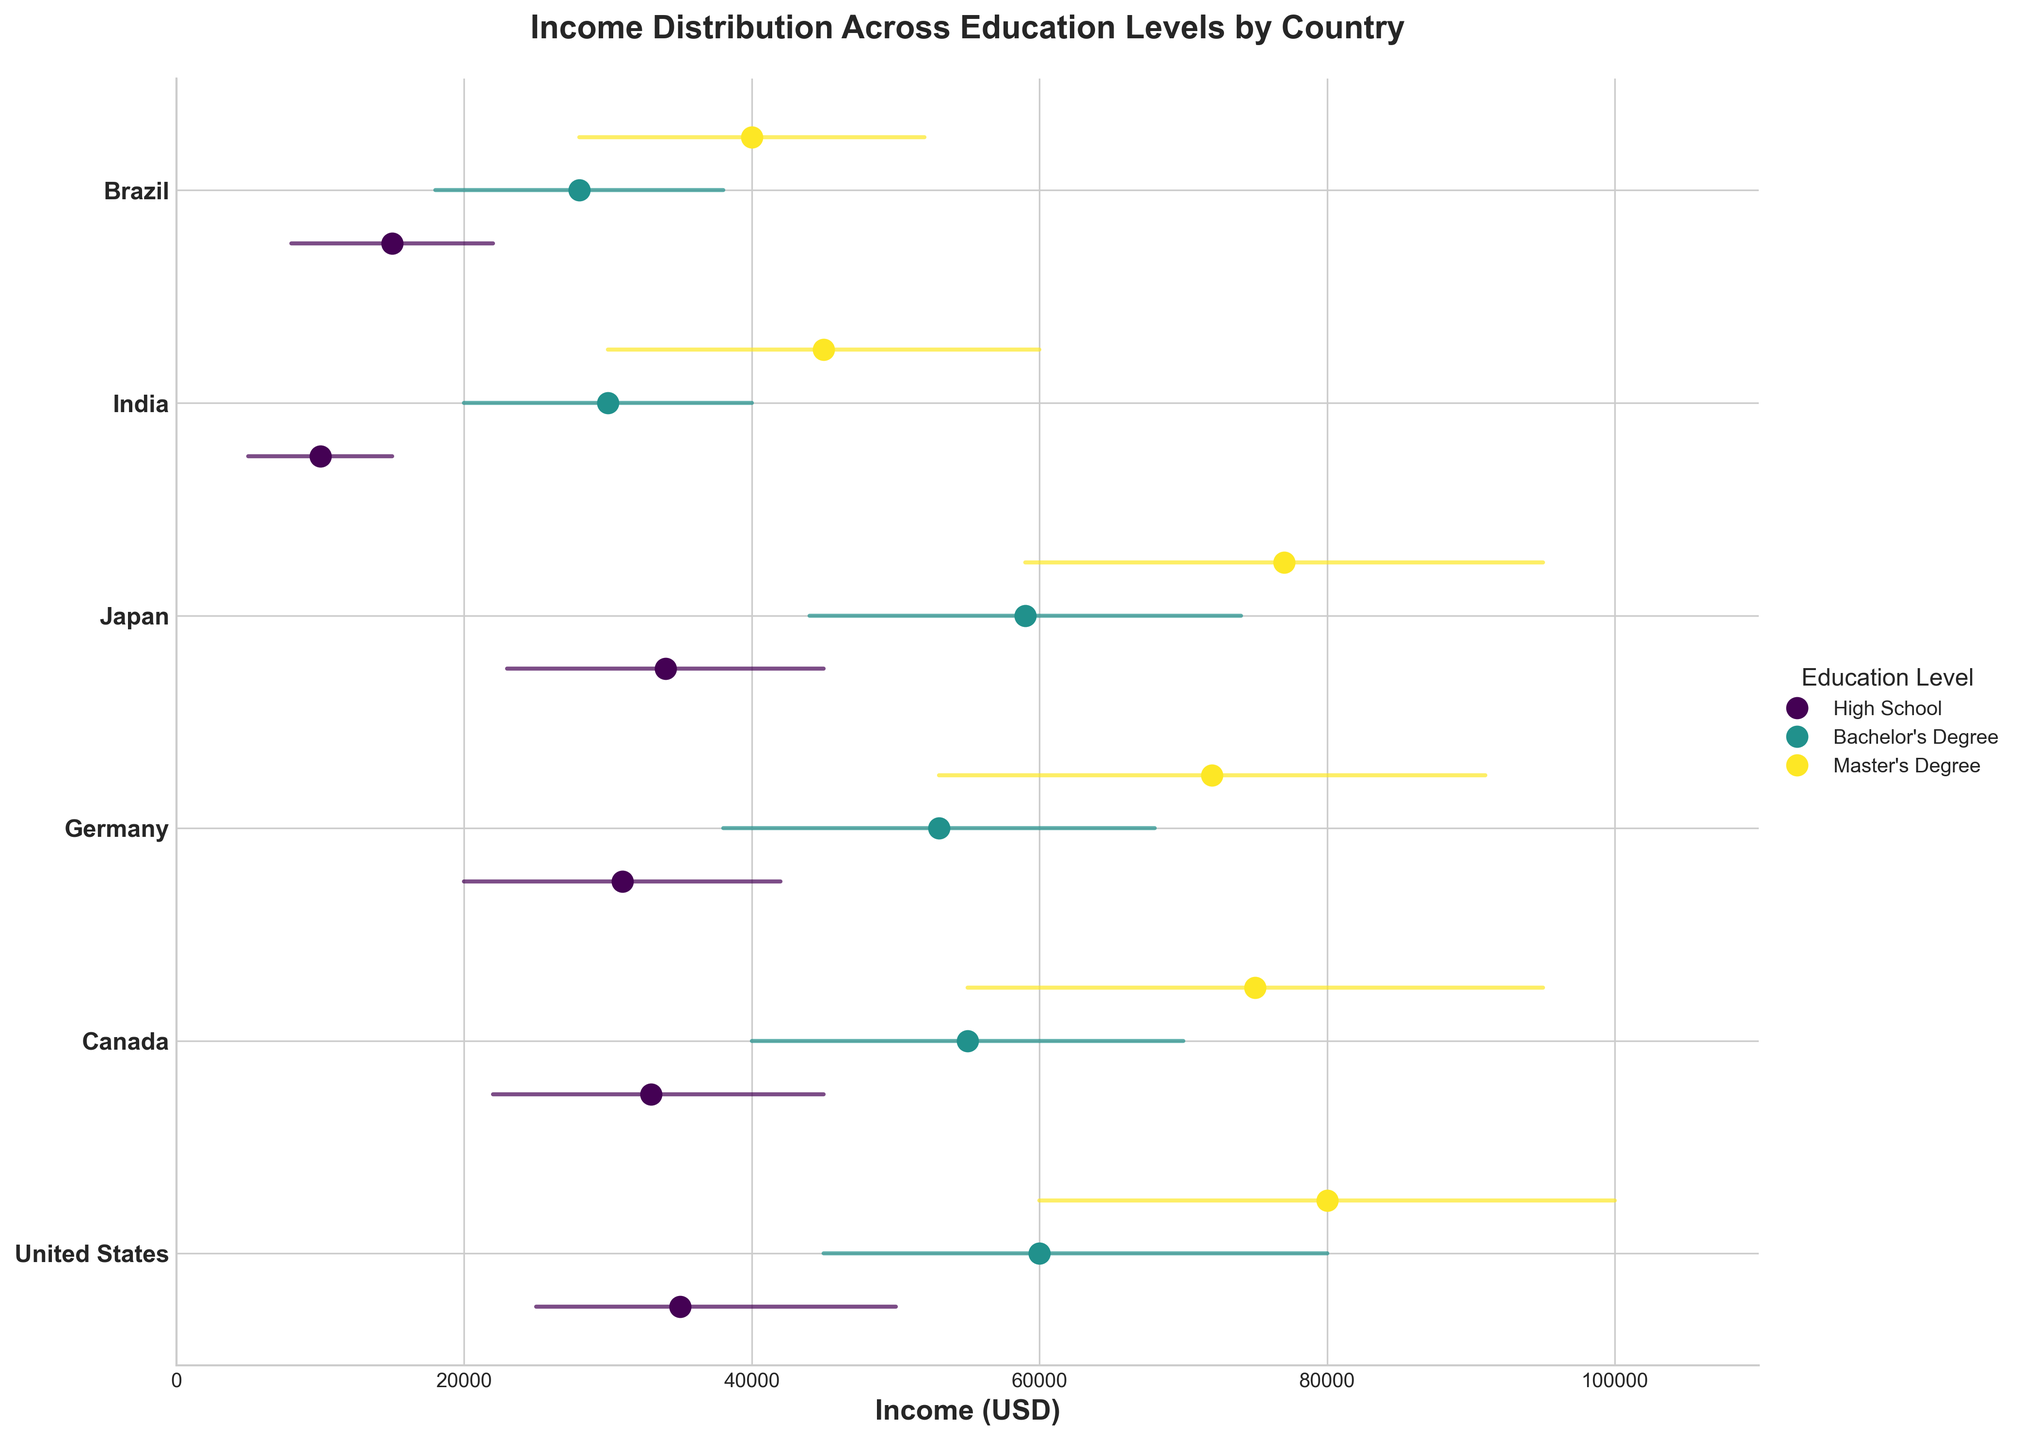What's the title of the figure? The title is displayed at the top of the figure in a larger and bold font. It reads "Income Distribution Across Education Levels by Country."
Answer: Income Distribution Across Education Levels by Country What is the median income for individuals with a Master's Degree in Germany? Look at the dot for "Germany" in the "Master's Degree" series. The label next to it provides the median income value.
Answer: 72000 Which country has the lowest median income for individuals with a high school education? Compare the median income for all countries in the "High School" series. Find the lowest value. India's median income for high school education is the lowest, as it is 10000.
Answer: India Is there a country where the median income for individuals with a Bachelor's degree is higher than the upper income for individuals with a Master's degree in another country? Compare all the median income values for Bachelor's degrees with the upper income values for Master's degrees from different countries. The median income for Bachelor's degree in the U.S. (60000) is higher than the upper income for Master's degree in Brazil (52000).
Answer: Yes What is the range of income (difference between upper and lower incomes) for Master's Degree holders in Canada? Identify the upper (95000) and lower (55000) incomes for Master's Degree holders in Canada. Subtract the lower income from the upper income (95000 - 55000).
Answer: 40000 Which country shows the smallest gap (median income) between Bachelor's Degree and Master's Degree holders? Calculate the difference between the median incomes of Bachelor's and Master's Degree holders in each country: U.S (20000), Canada (20000), Germany (19000), Japan (18000), India (15000), Brazil (12000). The smallest gap is observed in Brazil.
Answer: Brazil In which country do Master's Degree holders have the highest median income? Look at the median income dot for the Master's Degree for all countries and identify the highest value. Japan has the highest median income for Master's Degree holders at 77000.
Answer: Japan Are there any countries where the upper income for individuals with a high school education is higher than the lower income for individuals with a Bachelor's degree in the same country? Compare the upper income values for high school education with the lower income values for Bachelor's degree in each country. In Japan, the upper income for high school education (45000) is equal to the lower income for a Bachelor's degree (44000).
Answer: Yes What is the difference between the upper income of individuals with a Master's Degree in the United States and Canada? Identify the upper income for Master's Degree holders in both countries: U.S. (100000) and Canada (95000). Subtract the upper income of Canada from the upper income of the U.S. (100000 - 95000).
Answer: 5000 